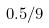Convert formula to latex. <formula><loc_0><loc_0><loc_500><loc_500>0 . 5 / 9</formula> 